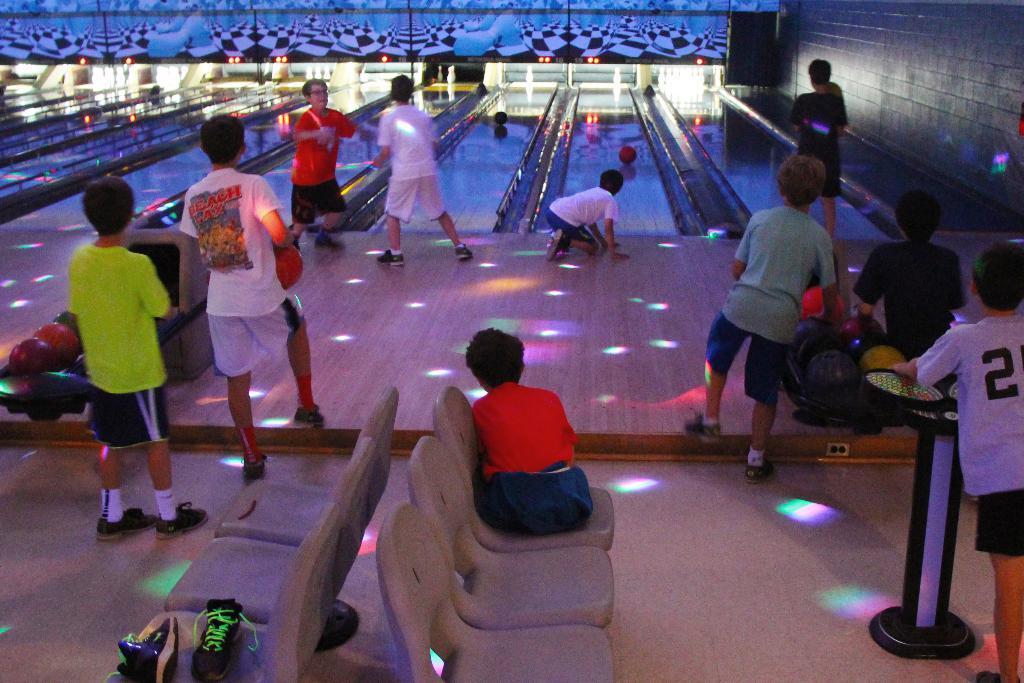In one or two sentences, can you explain what this image depicts? In this image in front there are shoes on the chair. There is a boy sitting on the chair. Beside him there are a few other chairs. There are boys holding the ball. In front of them there are a few boys bowling. On the right side of the image there is a wall. At the bottom of the image there is a floor. In the background of the image there are lights. 